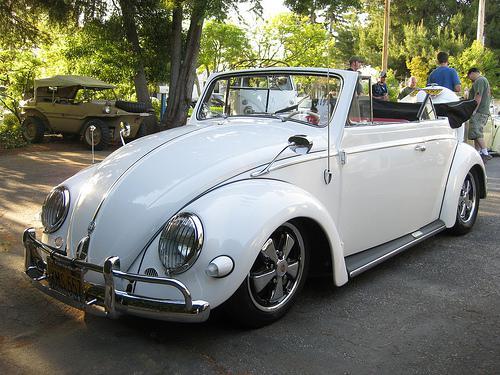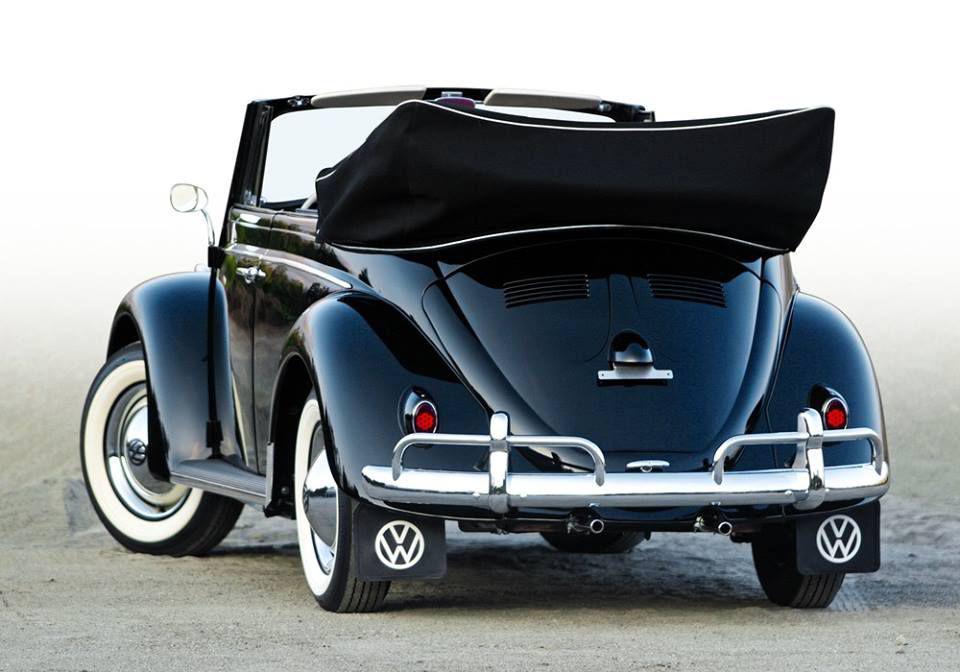The first image is the image on the left, the second image is the image on the right. Evaluate the accuracy of this statement regarding the images: "One of the cars is parked entirely in grass.". Is it true? Answer yes or no. No. The first image is the image on the left, the second image is the image on the right. Assess this claim about the two images: "An image shows a non-white rear-facing convertible that is not parked on grass.". Correct or not? Answer yes or no. Yes. 